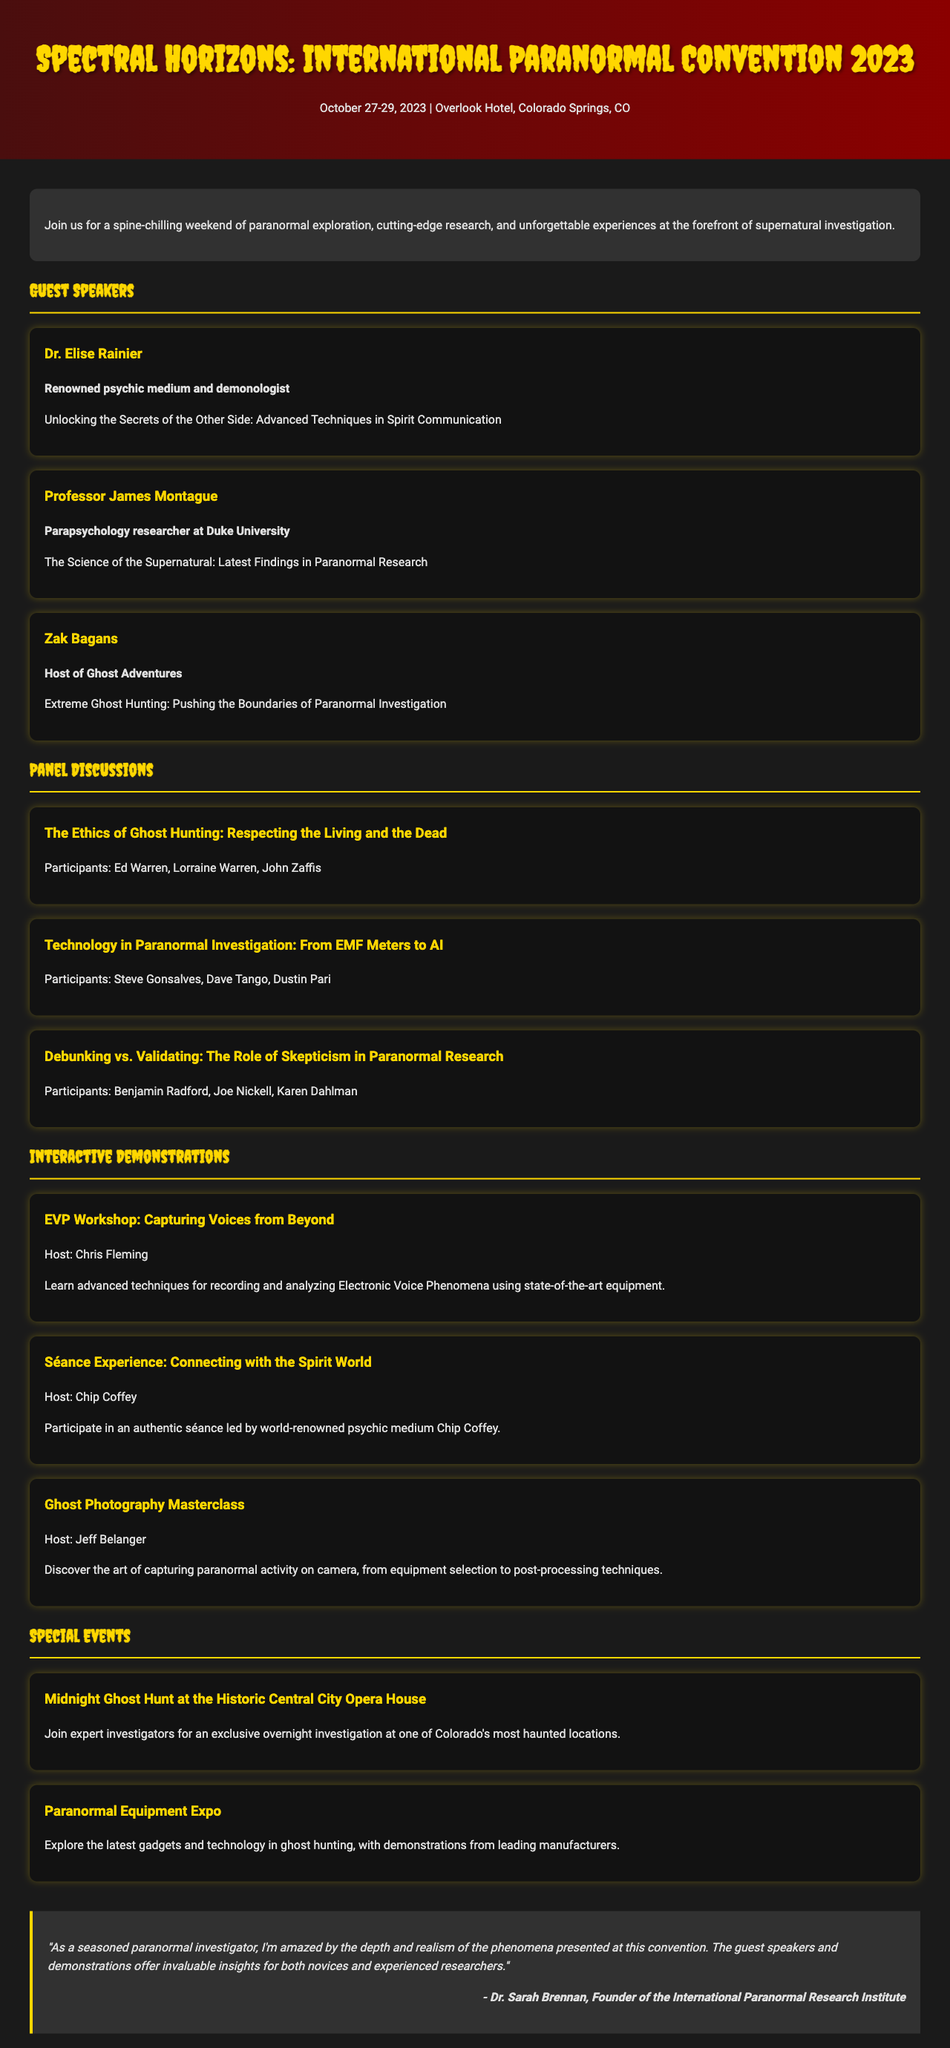What are the dates of the convention? The dates of the convention are explicitly stated in the document as the event dates.
Answer: October 27-29, 2023 Who is hosting the EVP Workshop? The document specifies the host of the EVP Workshop within the interactive demonstrations section.
Answer: Chris Fleming What is the title of Dr. Elise Rainier's presentation? The title of Dr. Elise Rainier's presentation is mentioned in the guest speakers section.
Answer: Unlocking the Secrets of the Other Side: Advanced Techniques in Spirit Communication How many guest speakers are featured at the convention? The total number of guest speakers can be counted from the guest speakers section of the document.
Answer: 3 What is the location of the venue? The venue location is clearly indicated in the document.
Answer: Overlook Hotel, Colorado Springs, CO Who will participate in the panel discussion about technology in paranormal investigation? The participants for the panel discussion are listed in the panels section of the document.
Answer: Steve Gonsalves, Dave Tango, Dustin Pari What event occurs at the Historic Central City Opera House? The document mentions this specific event along with its description in the special events section.
Answer: Midnight Ghost Hunt at the Historic Central City Opera House Who is the author of the testimonial? The document contains the name of the author in the testimonial section.
Answer: Dr. Sarah Brennan 